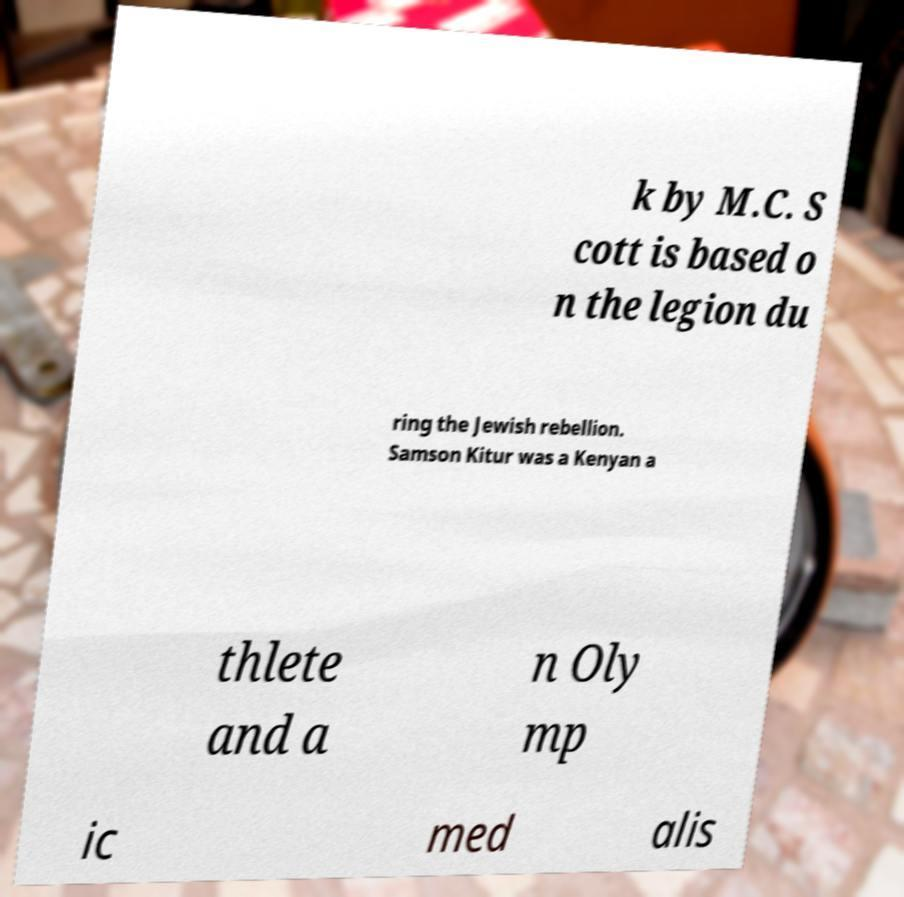Please read and relay the text visible in this image. What does it say? k by M.C. S cott is based o n the legion du ring the Jewish rebellion. Samson Kitur was a Kenyan a thlete and a n Oly mp ic med alis 